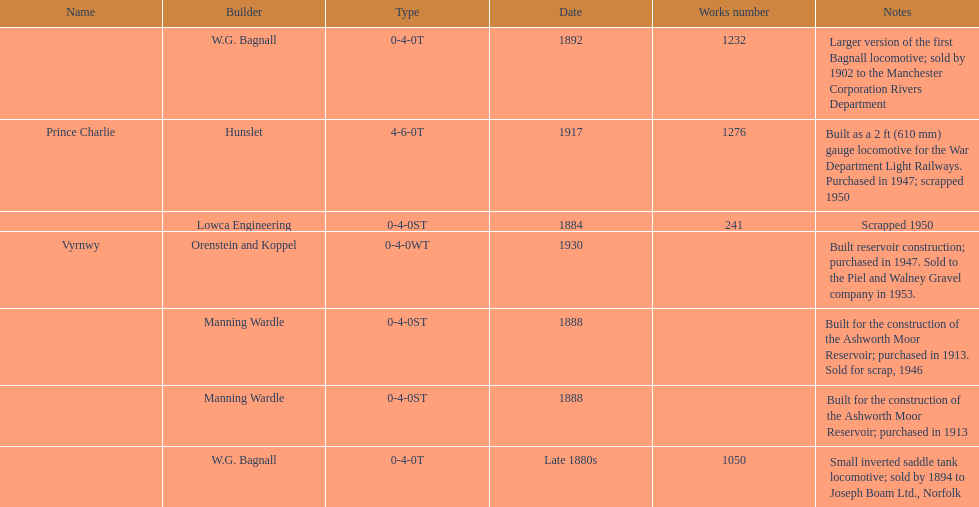How many steam locomotives were created before the 1900s? 5. Parse the table in full. {'header': ['Name', 'Builder', 'Type', 'Date', 'Works number', 'Notes'], 'rows': [['', 'W.G. Bagnall', '0-4-0T', '1892', '1232', 'Larger version of the first Bagnall locomotive; sold by 1902 to the Manchester Corporation Rivers Department'], ['Prince Charlie', 'Hunslet', '4-6-0T', '1917', '1276', 'Built as a 2\xa0ft (610\xa0mm) gauge locomotive for the War Department Light Railways. Purchased in 1947; scrapped 1950'], ['', 'Lowca Engineering', '0-4-0ST', '1884', '241', 'Scrapped 1950'], ['Vyrnwy', 'Orenstein and Koppel', '0-4-0WT', '1930', '', 'Built reservoir construction; purchased in 1947. Sold to the Piel and Walney Gravel company in 1953.'], ['', 'Manning Wardle', '0-4-0ST', '1888', '', 'Built for the construction of the Ashworth Moor Reservoir; purchased in 1913. Sold for scrap, 1946'], ['', 'Manning Wardle', '0-4-0ST', '1888', '', 'Built for the construction of the Ashworth Moor Reservoir; purchased in 1913'], ['', 'W.G. Bagnall', '0-4-0T', 'Late 1880s', '1050', 'Small inverted saddle tank locomotive; sold by 1894 to Joseph Boam Ltd., Norfolk']]} 